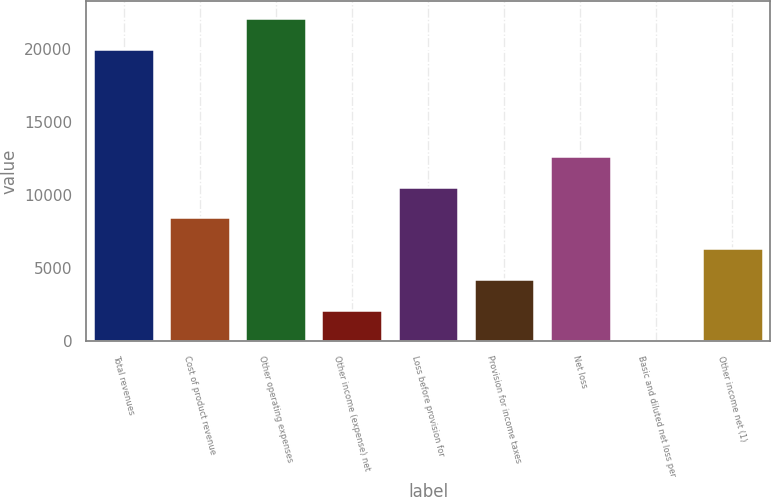Convert chart to OTSL. <chart><loc_0><loc_0><loc_500><loc_500><bar_chart><fcel>Total revenues<fcel>Cost of product revenue<fcel>Other operating expenses<fcel>Other income (expense) net<fcel>Loss before provision for<fcel>Provision for income taxes<fcel>Net loss<fcel>Basic and diluted net loss per<fcel>Other income net (1)<nl><fcel>19999<fcel>8463.7<fcel>22114.9<fcel>2116.06<fcel>10579.6<fcel>4231.94<fcel>12695.5<fcel>0.18<fcel>6347.82<nl></chart> 